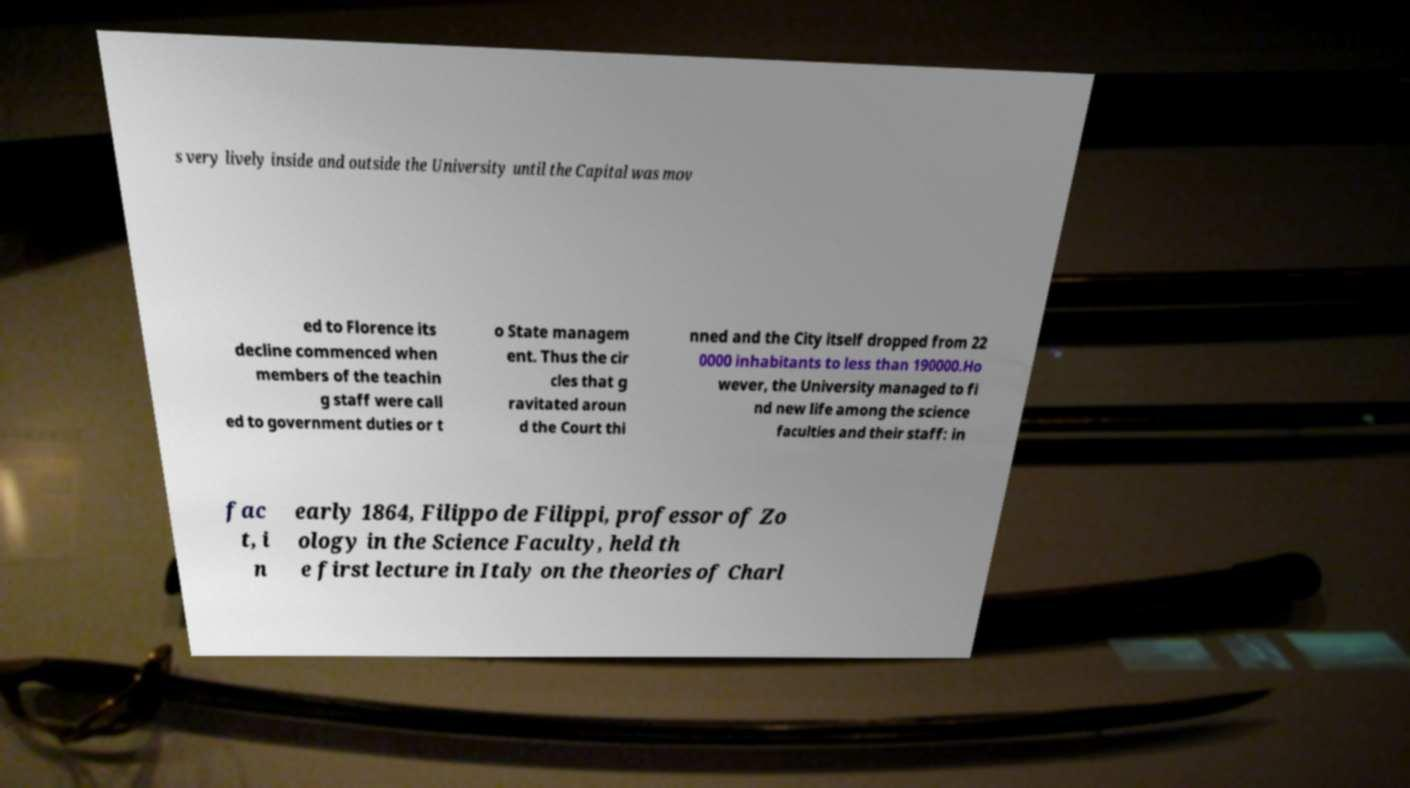Could you extract and type out the text from this image? s very lively inside and outside the University until the Capital was mov ed to Florence its decline commenced when members of the teachin g staff were call ed to government duties or t o State managem ent. Thus the cir cles that g ravitated aroun d the Court thi nned and the City itself dropped from 22 0000 inhabitants to less than 190000.Ho wever, the University managed to fi nd new life among the science faculties and their staff: in fac t, i n early 1864, Filippo de Filippi, professor of Zo ology in the Science Faculty, held th e first lecture in Italy on the theories of Charl 